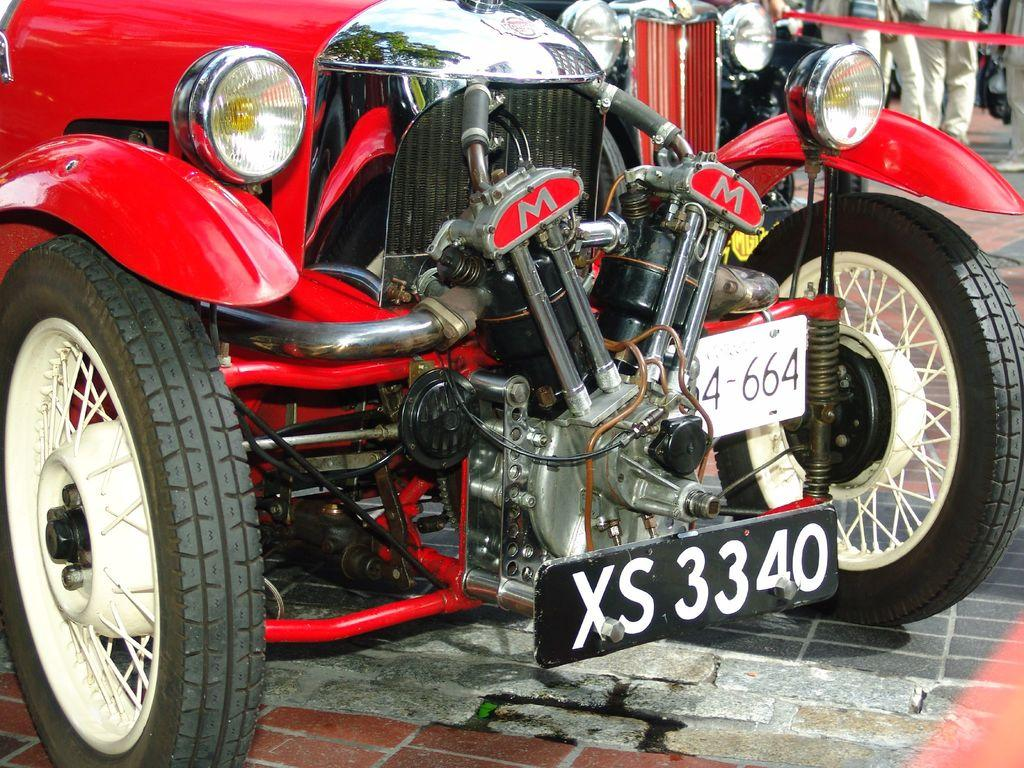What type of vehicle is the main subject of the picture? There is a vintage car in the picture. What is the color of the vintage car? The vintage car is red in color. Where is the vintage car located in the picture? The vintage car is parked on a path. Are there any other vehicles in the picture? Yes, there is another car in the picture. What else can be seen in the picture besides the cars? There are people standing near the cars. What type of cattle can be seen grazing near the vintage car in the image? There are no cattle present in the image; it features a vintage car parked on a path with people standing nearby. What type of writing can be seen on the vintage car in the image? There is no writing visible on the vintage car in the image. 